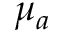Convert formula to latex. <formula><loc_0><loc_0><loc_500><loc_500>\mu _ { a }</formula> 